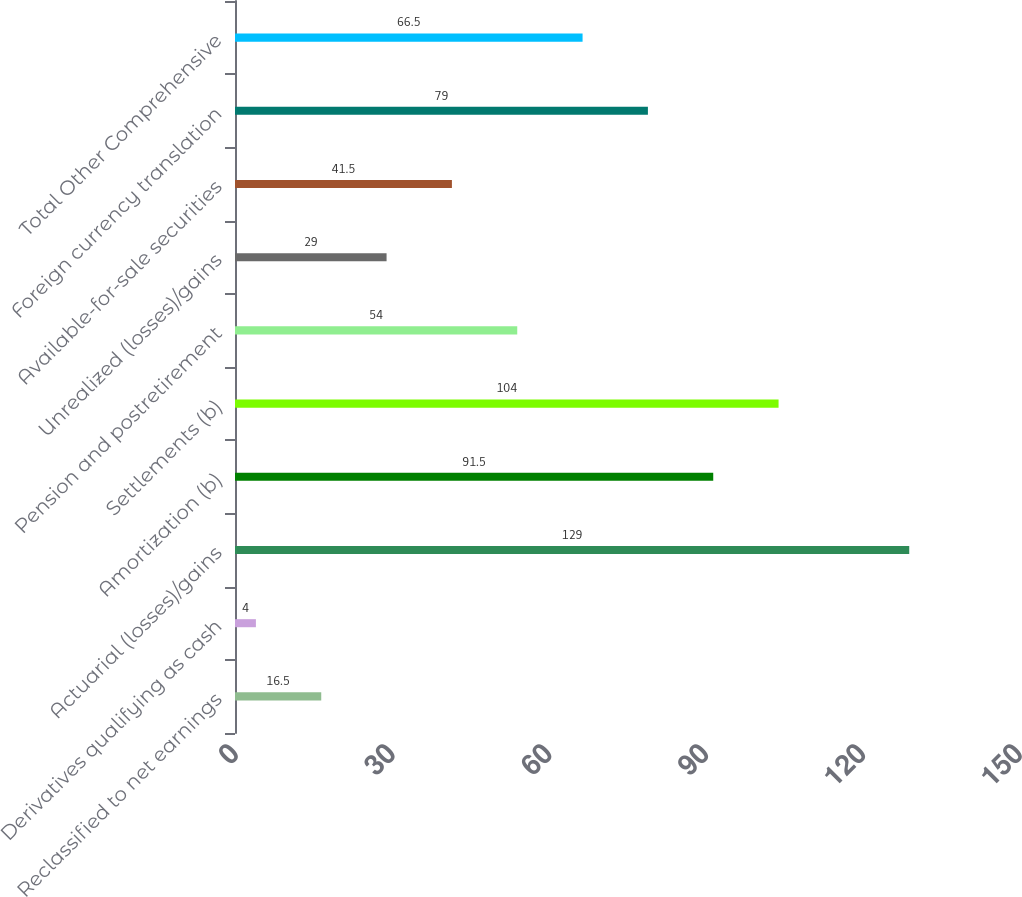Convert chart to OTSL. <chart><loc_0><loc_0><loc_500><loc_500><bar_chart><fcel>Reclassified to net earnings<fcel>Derivatives qualifying as cash<fcel>Actuarial (losses)/gains<fcel>Amortization (b)<fcel>Settlements (b)<fcel>Pension and postretirement<fcel>Unrealized (losses)/gains<fcel>Available-for-sale securities<fcel>Foreign currency translation<fcel>Total Other Comprehensive<nl><fcel>16.5<fcel>4<fcel>129<fcel>91.5<fcel>104<fcel>54<fcel>29<fcel>41.5<fcel>79<fcel>66.5<nl></chart> 